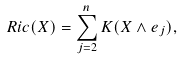<formula> <loc_0><loc_0><loc_500><loc_500>R i c ( X ) = \sum _ { j = 2 } ^ { n } K ( X \wedge e _ { j } ) ,</formula> 